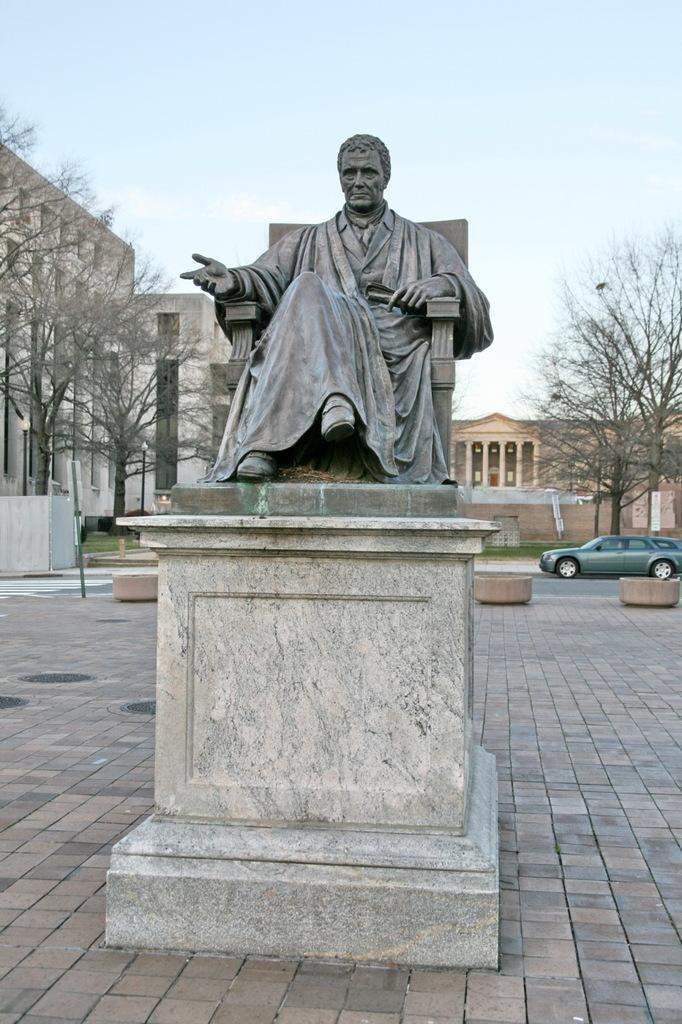What is the main subject in the center of the image? There is a statue in the center of the image. What can be seen in the background of the image? There are buildings, trees, a vehicle, and grass in the background of the image. What is at the bottom of the image? There is a walkway at the bottom of the image. What type of straw is the woman using to poison the statue in the image? There is no woman or poison present in the image; it features a statue and various background elements. 